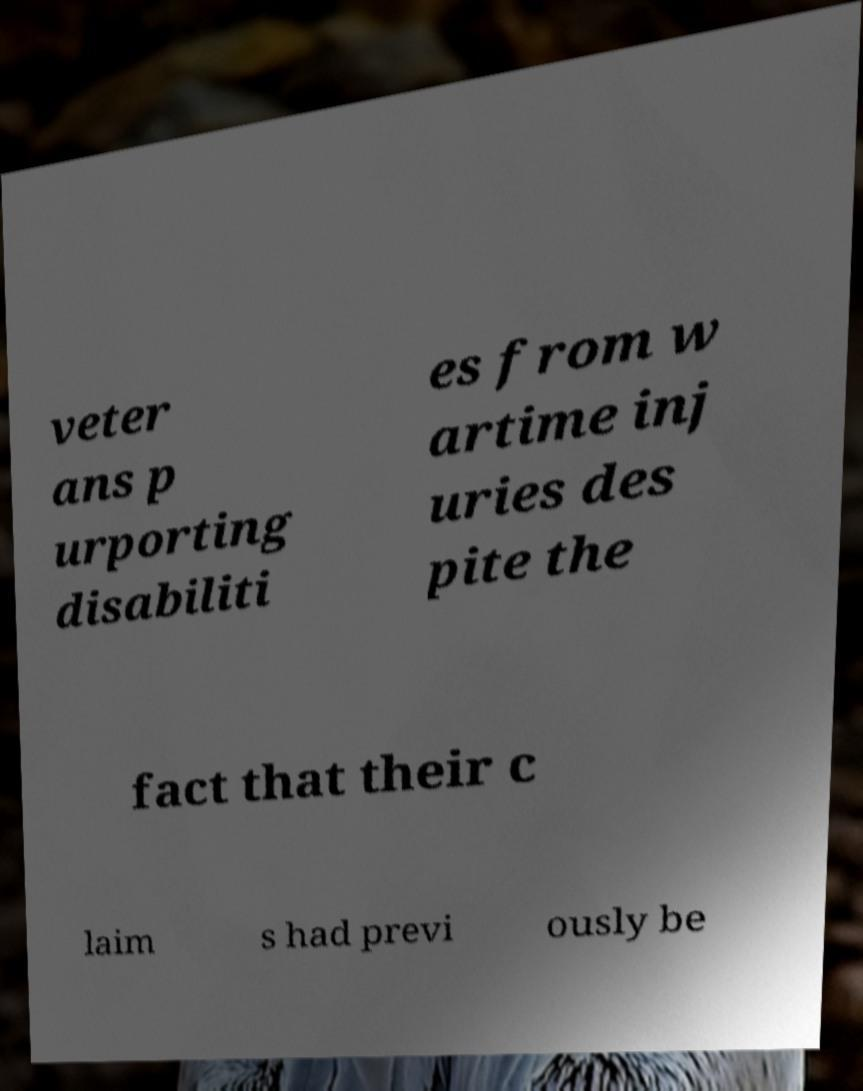Please identify and transcribe the text found in this image. veter ans p urporting disabiliti es from w artime inj uries des pite the fact that their c laim s had previ ously be 